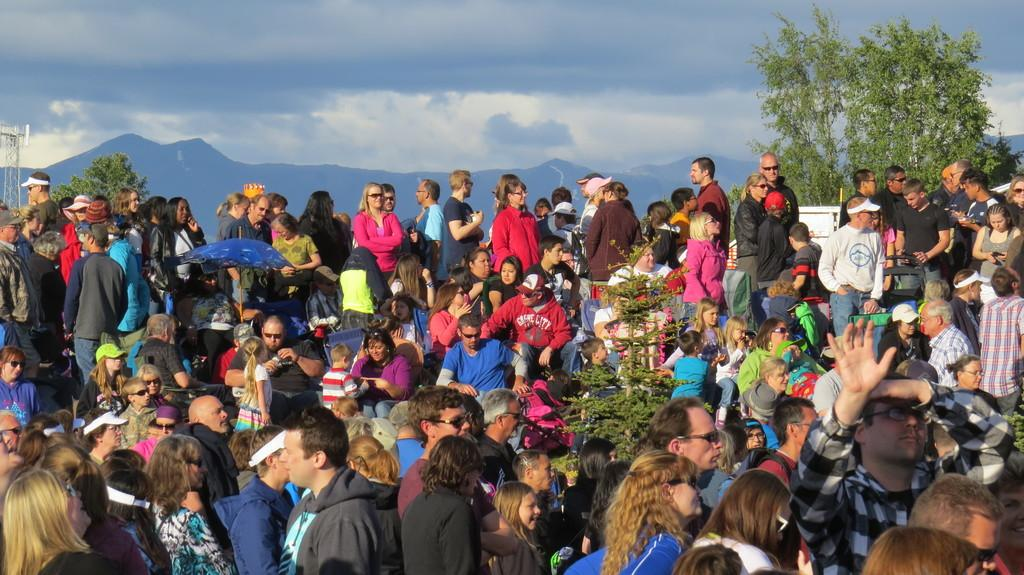What is the main subject of the image? The main subject of the image is a huge crowd of people. Can you describe any other elements in the image besides the crowd? Yes, there is a plant in the middle of the image, trees, mountains in the background, and clouds in the sky. What songs are being sung by the donkey in the image? There is no donkey present in the image, so no songs can be heard or seen. 